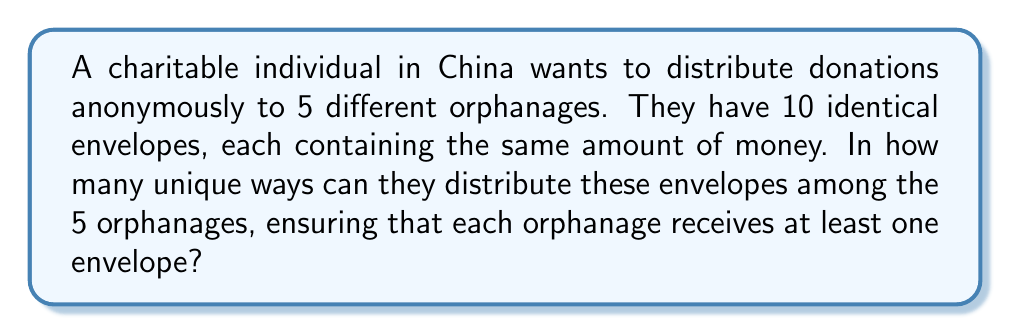What is the answer to this math problem? Let's approach this step-by-step using the stars and bars method:

1) We have 10 identical envelopes (stars) to distribute among 5 orphanages (bars).

2) Each orphanage must receive at least one envelope, so we start by giving one envelope to each orphanage. This leaves us with 5 envelopes to distribute.

3) Now, we need to find the number of ways to distribute 5 identical objects (remaining envelopes) into 5 distinct groups (orphanages).

4) This is equivalent to finding the number of ways to place 4 dividers (bars) among 5 objects (stars).

5) The total number of positions for stars and bars is 5 + 4 = 9.

6) We need to choose 4 positions for the bars out of these 9 positions.

7) This is a combination problem, represented as $\binom{9}{4}$ or $C(9,4)$.

8) We can calculate this using the formula:

   $$\binom{9}{4} = \frac{9!}{4!(9-4)!} = \frac{9!}{4!5!}$$

9) Calculating:
   $$\frac{9 \cdot 8 \cdot 7 \cdot 6 \cdot 5!}{(4 \cdot 3 \cdot 2 \cdot 1) \cdot 5!} = \frac{3024}{24} = 126$$

Therefore, there are 126 unique ways to distribute the donations.
Answer: 126 